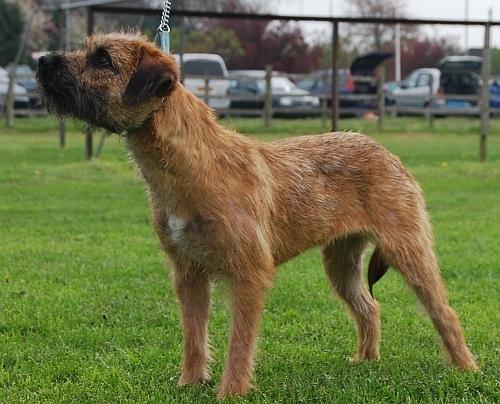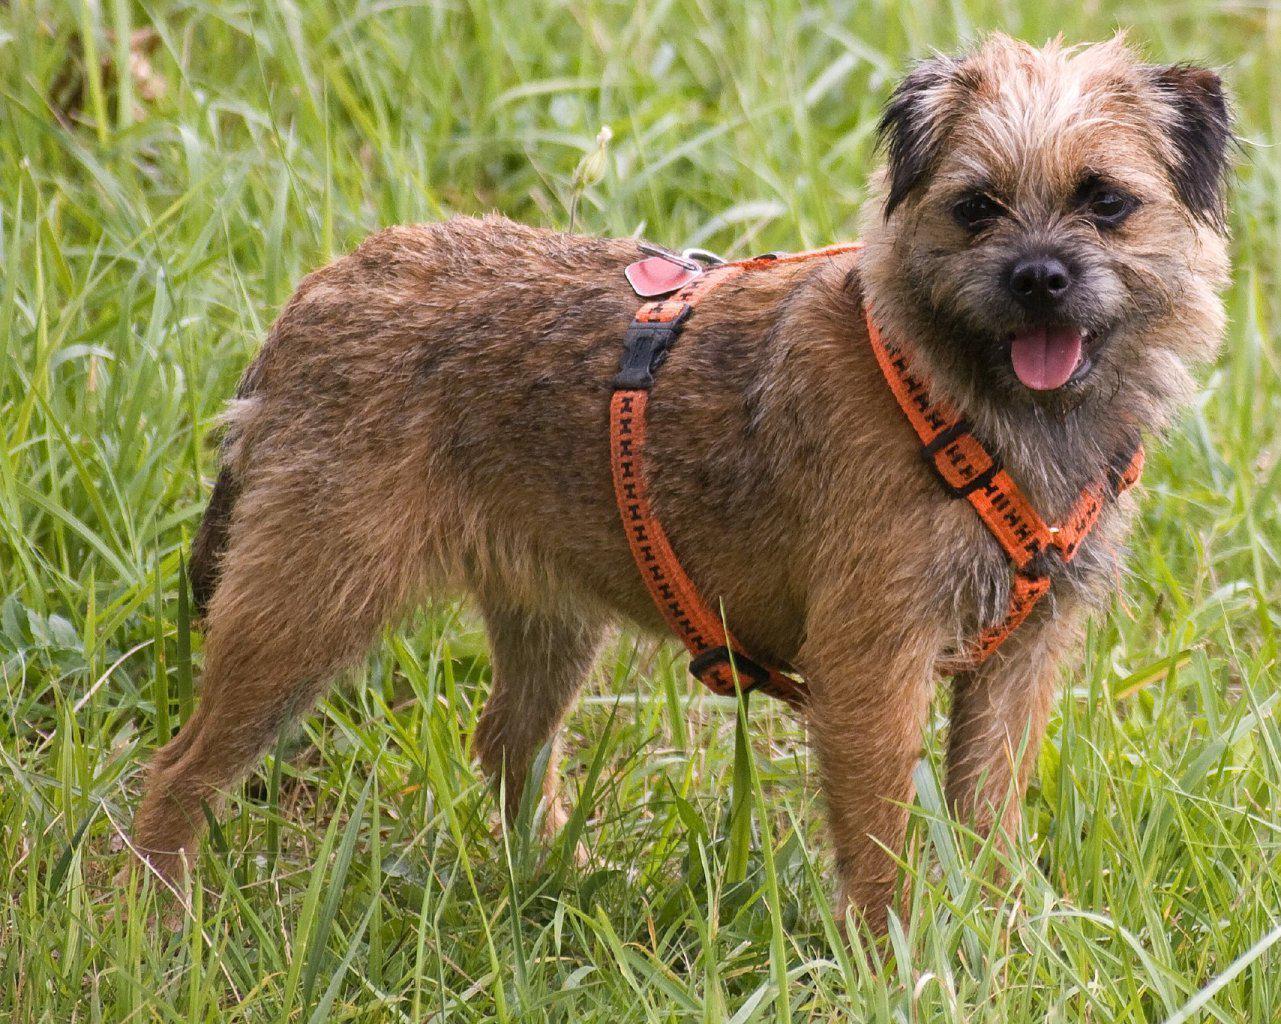The first image is the image on the left, the second image is the image on the right. Considering the images on both sides, is "The dogs in the images are standing with bodies turned in opposite directions." valid? Answer yes or no. Yes. 